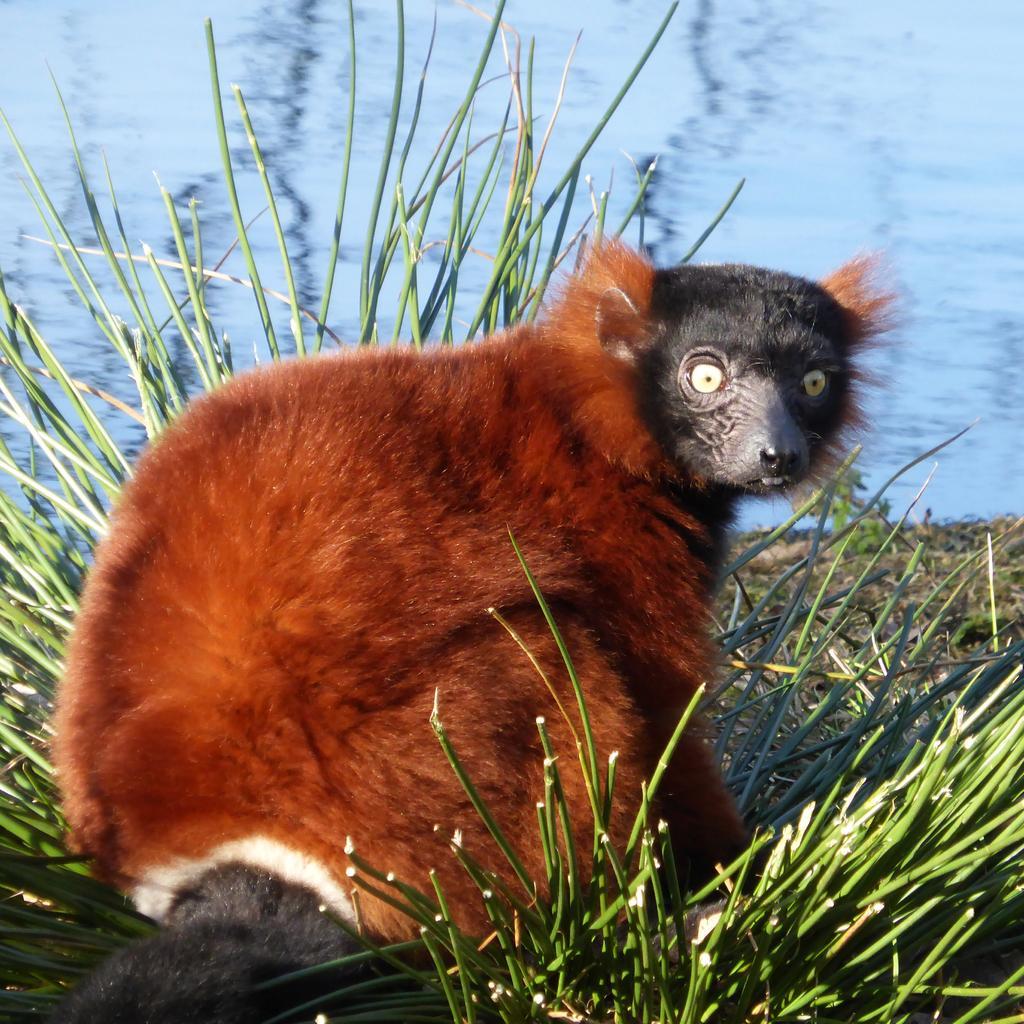Please provide a concise description of this image. Here we can see an animal in brown and black color. Beside this animal there is a grass. Background we can see water. 